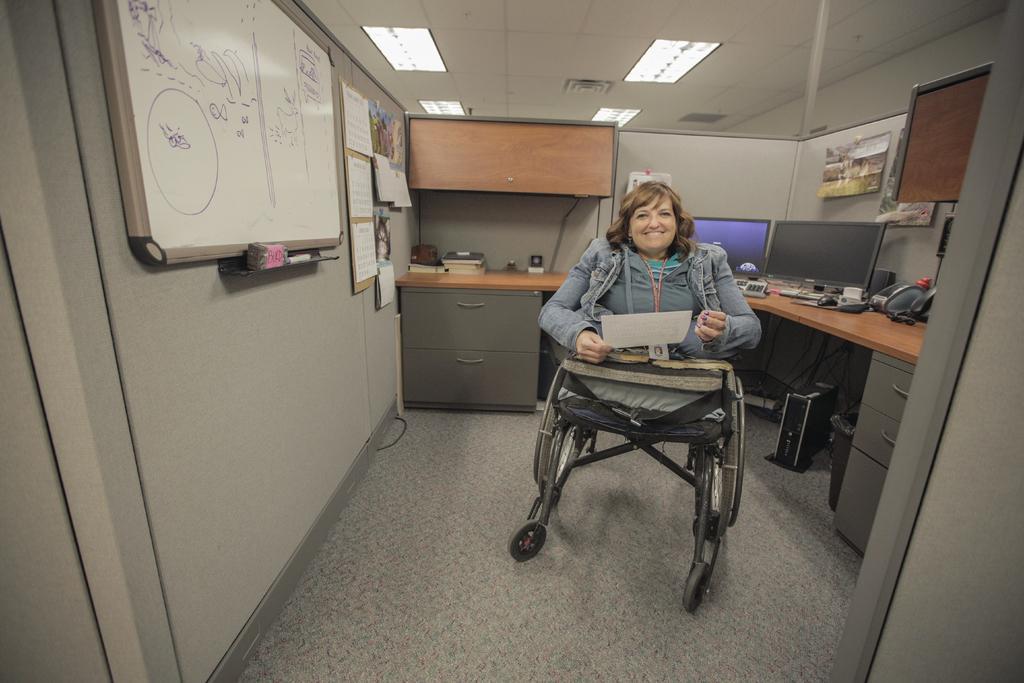How would you summarize this image in a sentence or two? Here in this picture the is sitting on a wheel chair. She is holding a paper. To the left hand side there is a board. And we can see a table with cupboards. And to the right side there is a monitors on the table and cpu. 